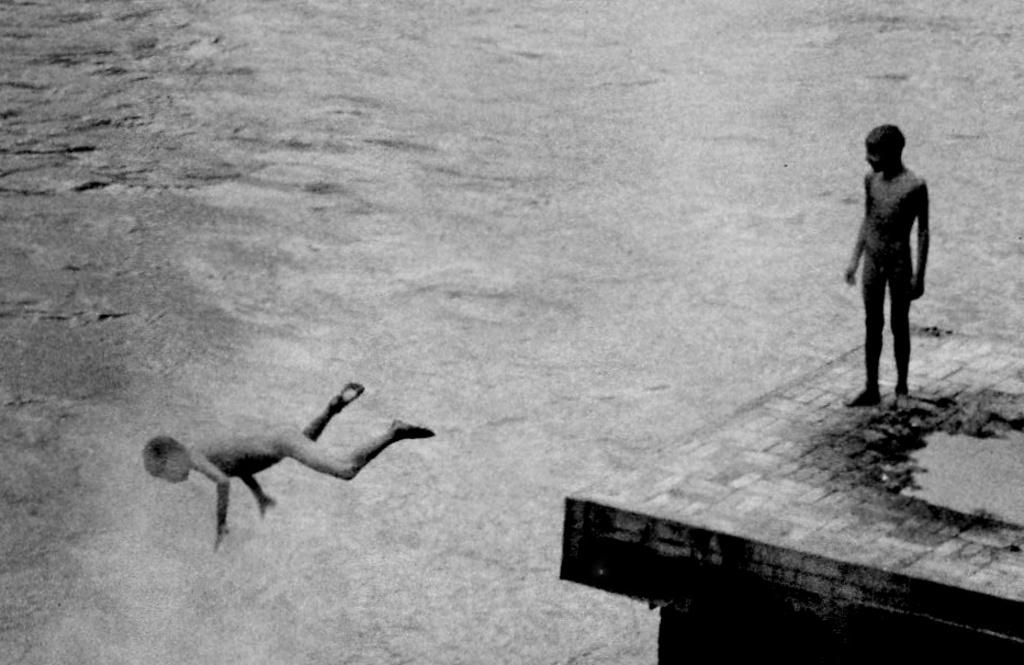What is the color scheme of the image? The image is black and white. How many kids are present in the image? There are two kids in the image. What can be seen in the background of the image? There is water visible in the image. What type of structure is present in the image? There is a platform in the image. What game are the boys playing in the image? There are no boys present in the image, and no game is being played. 